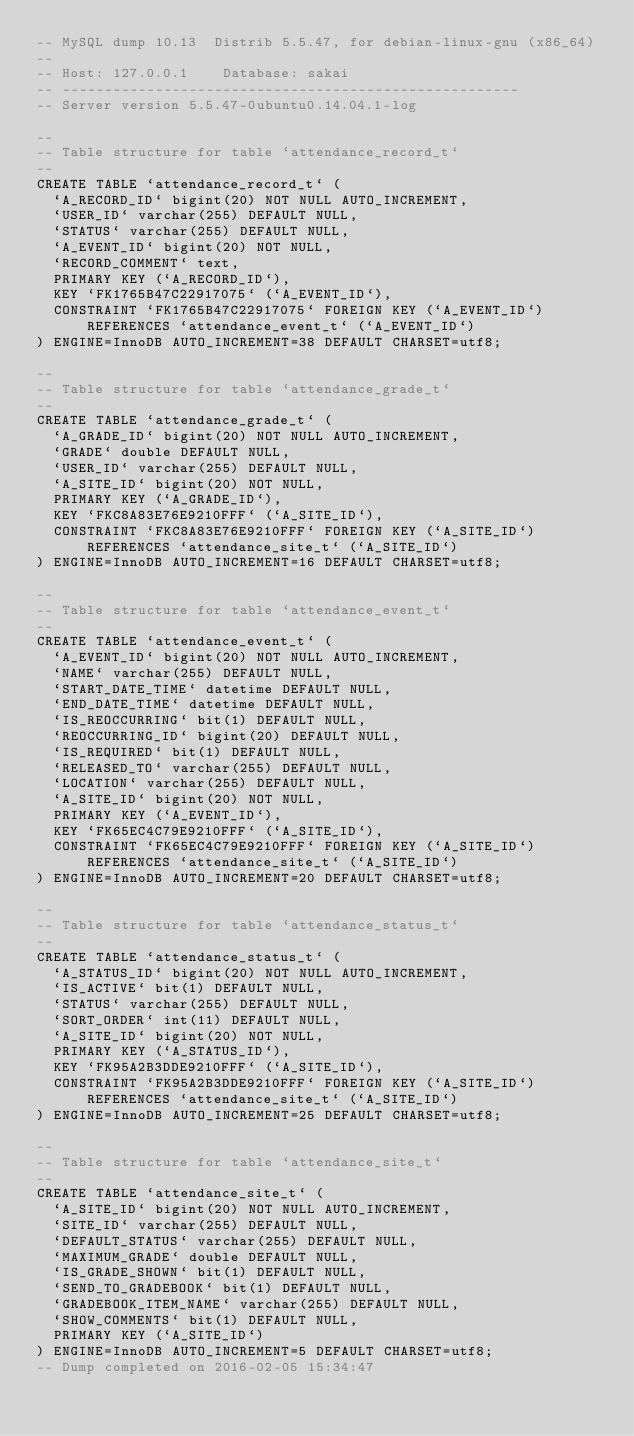Convert code to text. <code><loc_0><loc_0><loc_500><loc_500><_SQL_>-- MySQL dump 10.13  Distrib 5.5.47, for debian-linux-gnu (x86_64)
--
-- Host: 127.0.0.1    Database: sakai
-- ------------------------------------------------------
-- Server version	5.5.47-0ubuntu0.14.04.1-log

--
-- Table structure for table `attendance_record_t`
--
CREATE TABLE `attendance_record_t` (
  `A_RECORD_ID` bigint(20) NOT NULL AUTO_INCREMENT,
  `USER_ID` varchar(255) DEFAULT NULL,
  `STATUS` varchar(255) DEFAULT NULL,
  `A_EVENT_ID` bigint(20) NOT NULL,
  `RECORD_COMMENT` text,
  PRIMARY KEY (`A_RECORD_ID`),
  KEY `FK1765B47C22917075` (`A_EVENT_ID`),
  CONSTRAINT `FK1765B47C22917075` FOREIGN KEY (`A_EVENT_ID`) REFERENCES `attendance_event_t` (`A_EVENT_ID`)
) ENGINE=InnoDB AUTO_INCREMENT=38 DEFAULT CHARSET=utf8;

--
-- Table structure for table `attendance_grade_t`
--
CREATE TABLE `attendance_grade_t` (
  `A_GRADE_ID` bigint(20) NOT NULL AUTO_INCREMENT,
  `GRADE` double DEFAULT NULL,
  `USER_ID` varchar(255) DEFAULT NULL,
  `A_SITE_ID` bigint(20) NOT NULL,
  PRIMARY KEY (`A_GRADE_ID`),
  KEY `FKC8A83E76E9210FFF` (`A_SITE_ID`),
  CONSTRAINT `FKC8A83E76E9210FFF` FOREIGN KEY (`A_SITE_ID`) REFERENCES `attendance_site_t` (`A_SITE_ID`)
) ENGINE=InnoDB AUTO_INCREMENT=16 DEFAULT CHARSET=utf8;

--
-- Table structure for table `attendance_event_t`
--
CREATE TABLE `attendance_event_t` (
  `A_EVENT_ID` bigint(20) NOT NULL AUTO_INCREMENT,
  `NAME` varchar(255) DEFAULT NULL,
  `START_DATE_TIME` datetime DEFAULT NULL,
  `END_DATE_TIME` datetime DEFAULT NULL,
  `IS_REOCCURRING` bit(1) DEFAULT NULL,
  `REOCCURRING_ID` bigint(20) DEFAULT NULL,
  `IS_REQUIRED` bit(1) DEFAULT NULL,
  `RELEASED_TO` varchar(255) DEFAULT NULL,
  `LOCATION` varchar(255) DEFAULT NULL,
  `A_SITE_ID` bigint(20) NOT NULL,
  PRIMARY KEY (`A_EVENT_ID`),
  KEY `FK65EC4C79E9210FFF` (`A_SITE_ID`),
  CONSTRAINT `FK65EC4C79E9210FFF` FOREIGN KEY (`A_SITE_ID`) REFERENCES `attendance_site_t` (`A_SITE_ID`)
) ENGINE=InnoDB AUTO_INCREMENT=20 DEFAULT CHARSET=utf8;

--
-- Table structure for table `attendance_status_t`
--
CREATE TABLE `attendance_status_t` (
  `A_STATUS_ID` bigint(20) NOT NULL AUTO_INCREMENT,
  `IS_ACTIVE` bit(1) DEFAULT NULL,
  `STATUS` varchar(255) DEFAULT NULL,
  `SORT_ORDER` int(11) DEFAULT NULL,
  `A_SITE_ID` bigint(20) NOT NULL,
  PRIMARY KEY (`A_STATUS_ID`),
  KEY `FK95A2B3DDE9210FFF` (`A_SITE_ID`),
  CONSTRAINT `FK95A2B3DDE9210FFF` FOREIGN KEY (`A_SITE_ID`) REFERENCES `attendance_site_t` (`A_SITE_ID`)
) ENGINE=InnoDB AUTO_INCREMENT=25 DEFAULT CHARSET=utf8;

--
-- Table structure for table `attendance_site_t`
--
CREATE TABLE `attendance_site_t` (
  `A_SITE_ID` bigint(20) NOT NULL AUTO_INCREMENT,
  `SITE_ID` varchar(255) DEFAULT NULL,
  `DEFAULT_STATUS` varchar(255) DEFAULT NULL,
  `MAXIMUM_GRADE` double DEFAULT NULL,
  `IS_GRADE_SHOWN` bit(1) DEFAULT NULL,
  `SEND_TO_GRADEBOOK` bit(1) DEFAULT NULL,
  `GRADEBOOK_ITEM_NAME` varchar(255) DEFAULT NULL,
  `SHOW_COMMENTS` bit(1) DEFAULT NULL,
  PRIMARY KEY (`A_SITE_ID`)
) ENGINE=InnoDB AUTO_INCREMENT=5 DEFAULT CHARSET=utf8;
-- Dump completed on 2016-02-05 15:34:47
</code> 